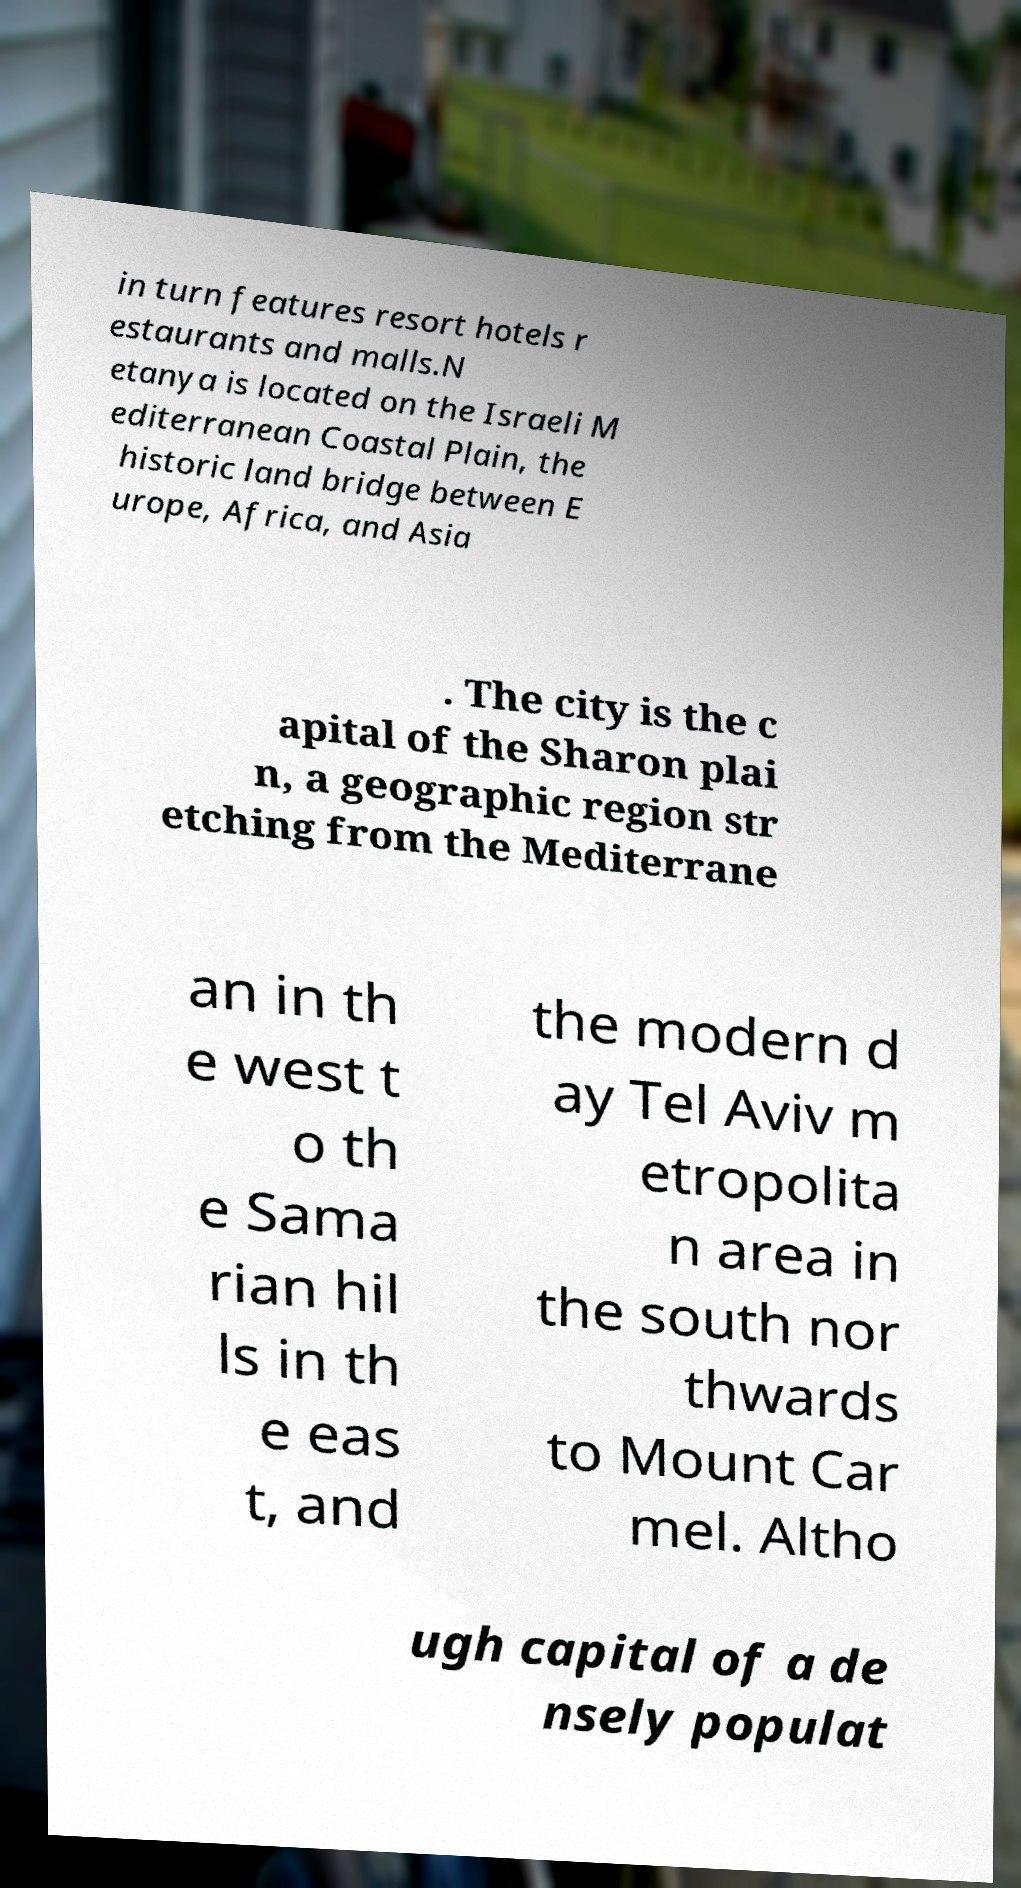For documentation purposes, I need the text within this image transcribed. Could you provide that? in turn features resort hotels r estaurants and malls.N etanya is located on the Israeli M editerranean Coastal Plain, the historic land bridge between E urope, Africa, and Asia . The city is the c apital of the Sharon plai n, a geographic region str etching from the Mediterrane an in th e west t o th e Sama rian hil ls in th e eas t, and the modern d ay Tel Aviv m etropolita n area in the south nor thwards to Mount Car mel. Altho ugh capital of a de nsely populat 